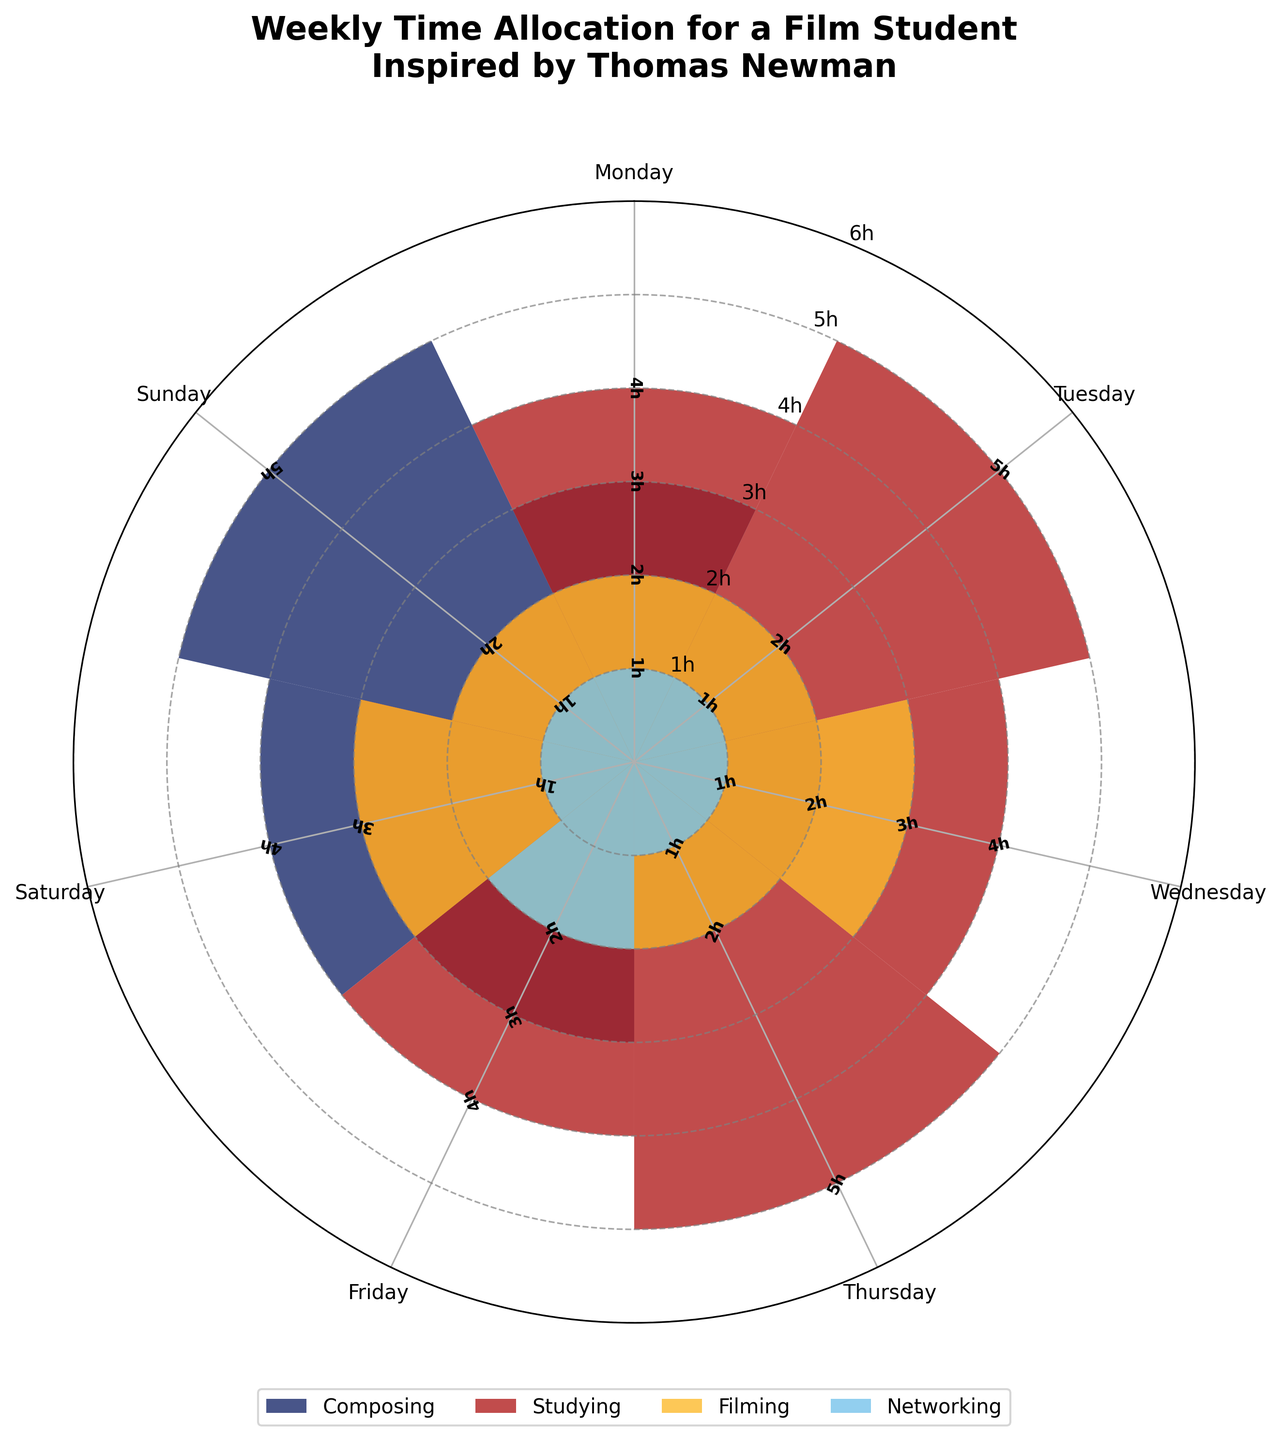What is the total number of hours spent on composing throughout the week? By looking at the values for each day under composing: 3+2+2+2+3+4+5. Sum these values to get the total.
Answer: 21 hours Which day does the film student spend the most time studying? Check each day under studying and find the highest value. The highest value is 5 hours which occurs on both Tuesday and Thursday.
Answer: Tuesday and Thursday On average, how many hours does the film student spend on filming per day? Add up the hours spent on filming for each day: 2+2+3+2+2+3+2 and divide by 7 (number of days in the week).
Answer: 2.29 hours Does the film student spend more hours composing on weekends (Saturday and Sunday) compared to weekdays (Monday to Friday)? Sum the hours spent composing on Saturday and Sunday: 4+5 = 9. Sum the hours spent composing from Monday to Friday: 3+2+2+2+3 = 12. Compare the two sums.
Answer: Yes, weekends (9 hours) Between composing and networking, which activity has a more even distribution of time across the week? Refer to the variation in hours recorded for each day. Composing ranges between 2 to 5 hours, while networking remains between 1 to 2 hours.
Answer: Networking What is the most time-consuming activity overall? Sum the hours for each activity across the week. Identify the activity with the highest total sum. (Composing: 21, Studying: 27, Filming: 16, Networking: 8)
Answer: Studying How many hours in total are spent on networking during the weekends? Add up the hours spent on networking on Saturday and Sunday: 1+1.
Answer: 2 hours What day shows the least amount of overall activity? Sum the hours for all activities for each day, then identify the day with the minimum sum. (e.g., Monday: 3+4+2+1=10 hours)
Answer: Sunday On which day do composing and studying combined take up the most time? Add the hours spent composing and studying for each day and compare. The highest sum comes on Monday and Friday (both 7 hours).
Answer: Monday and Friday What is the range of hours spent on studying across the week? Find the minimum and maximum hours spent on studying: Min = 2 (Sunday), Max = 5 (Tuesday and Thursday). Range = Max - Min.
Answer: 3 hours 